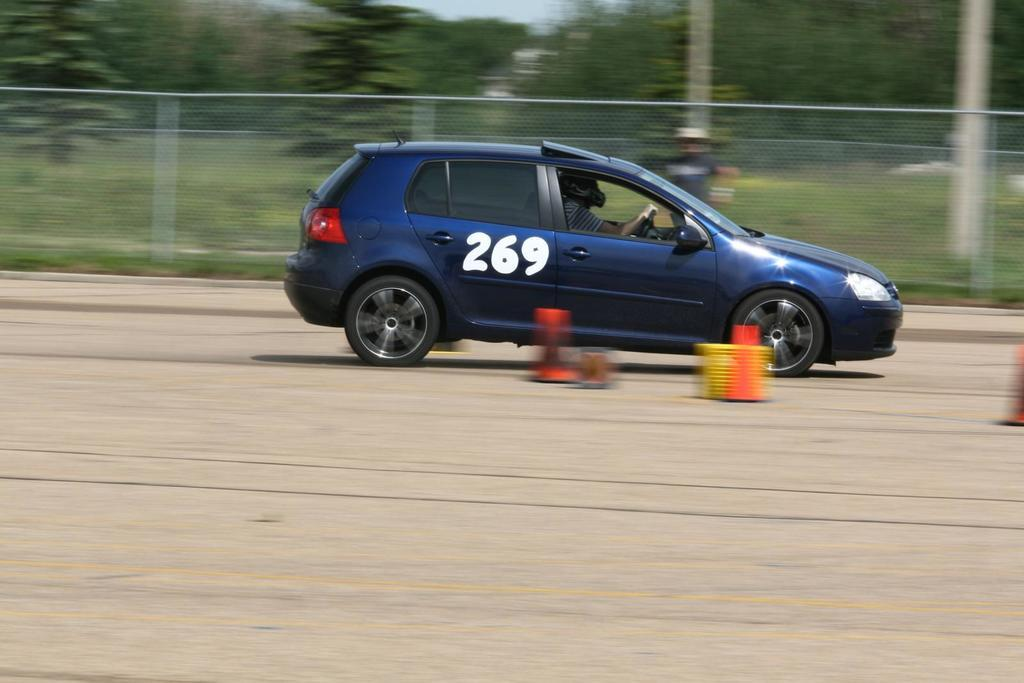What is the person in the image doing? The person is sitting in a motor vehicle in the image. Where is the motor vehicle located? The motor vehicle is on the road. What can be seen in the background of the image? There is a grill, trees, and the sky visible in the background of the image. What type of yard can be seen in the image? There is no yard present in the image; it features a person sitting in a motor vehicle on the road. What is the monetary value of the motor vehicle in the image? The value of the motor vehicle cannot be determined from the image alone. 